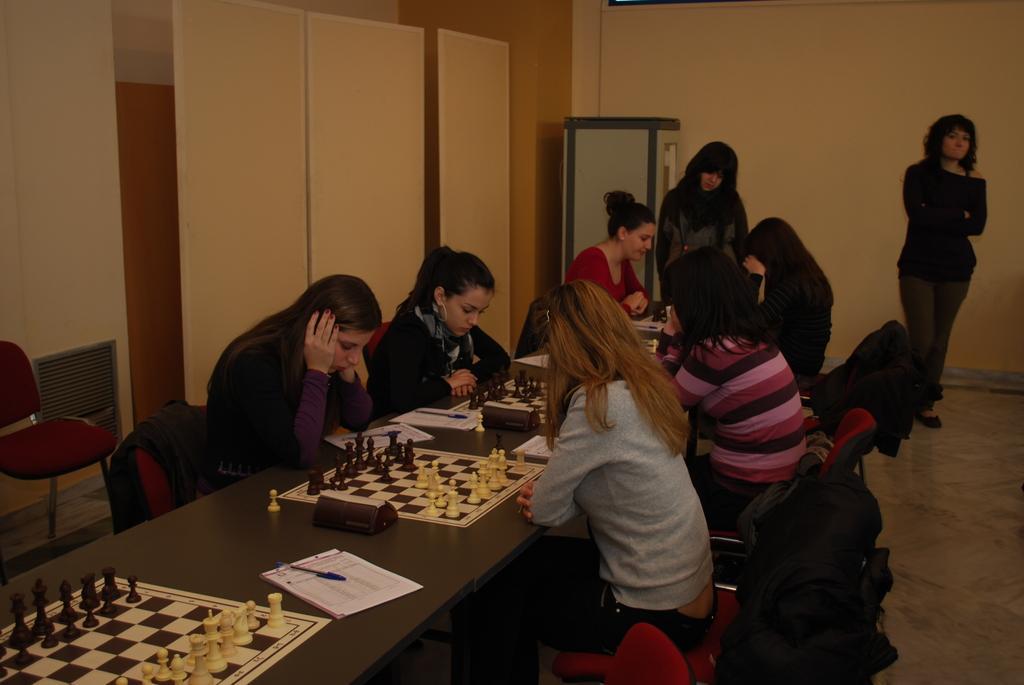How would you summarize this image in a sentence or two? In this image we can see six women sitting on chair in front of a table, they are playing a chess game, in the background the to a women standing one woman is looking at game, on the left side we can see a chair and a wall, there is a paper and pen on the table. 